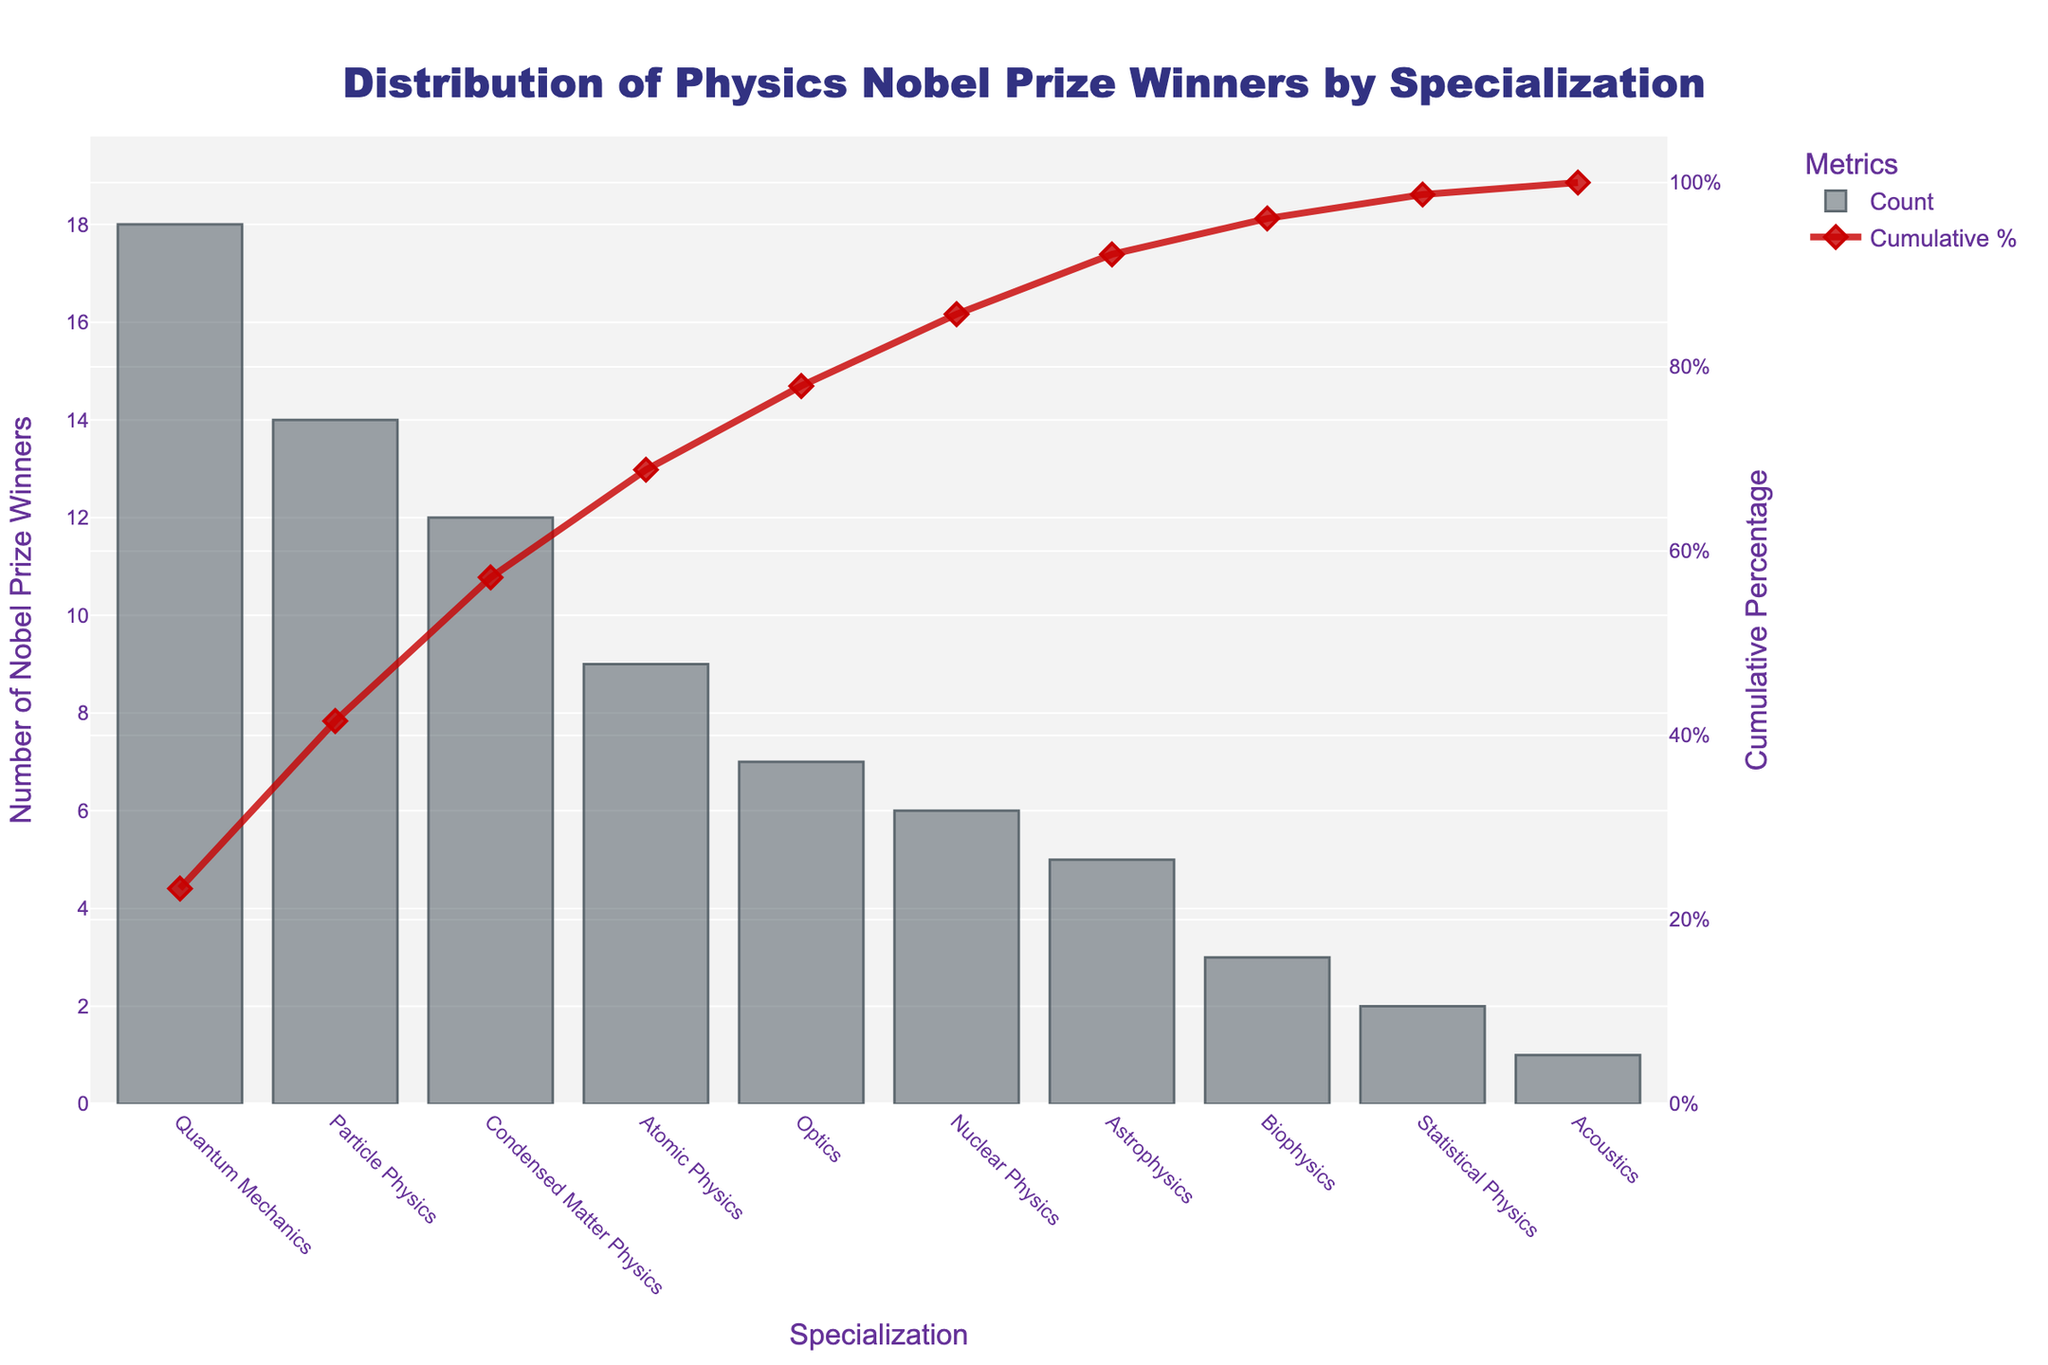what is the title of the figure? The title is often shown at the top of the chart and provides a summary of what the chart is about.
Answer: Distribution of Physics Nobel Prize Winners by Specialization What is the category with the highest count of Nobel Prize winners? The category with the highest count is the first one in the descending order of bars, with the tallest bar indicating the most winners.
Answer: Quantum Mechanics Which category has the lowest count of Nobel Prize winners? The category with the lowest count is the last one in the descending order of bars, having the shortest bar.
Answer: Acoustics What is the cumulative percentage for Particle Physics? The cumulative percentage for Particle Physics is indicated by the corresponding point on the red line above its bar in the upper x-axis.
Answer: Approximately 32% How many Nobel Prizes have been awarded in Atomic Physics and Optics combined? To get the total, add the counts from the bars representing Atomic Physics and Optics. That is 9 + 7.
Answer: 16 Which categories account for over 50% of all Nobel Prizes in physics? Check the cumulative percentage line to see which categories accumulate up to or just over 50%. These will be the first few categories that together achieve this value.
Answer: Quantum Mechanics, Particle Physics, and Condensed Matter Physics What percentage of Nobel Prizes in physics were awarded in the field of Astrophysics? Find the bar for Astrophysics and divide its count by the total sum of all counts, then multiply by 100 to get the percentage.
Answer: Approximately 6.4% How does the number of Nobel Prizes in Biophysics compare to Astrophysics? Compare the height of the bar for Biophysics to that for Astrophysics. The difference in their heights will show their comparative counts.
Answer: Biophysics has fewer Nobel Prizes than Astrophysics What is the cumulative percentage just before the 'Nuclear Physics' category? Find the cumulative percentage corresponding to the bar just before the Nuclear Physics category.
Answer: Approximately 87% How many more Nobel Prizes have been awarded in Quantum Mechanics compared to Astrophysics? To find the difference, subtract the count of Astrophysics from the count of Quantum Mechanics. That is 18 - 5.
Answer: 13 